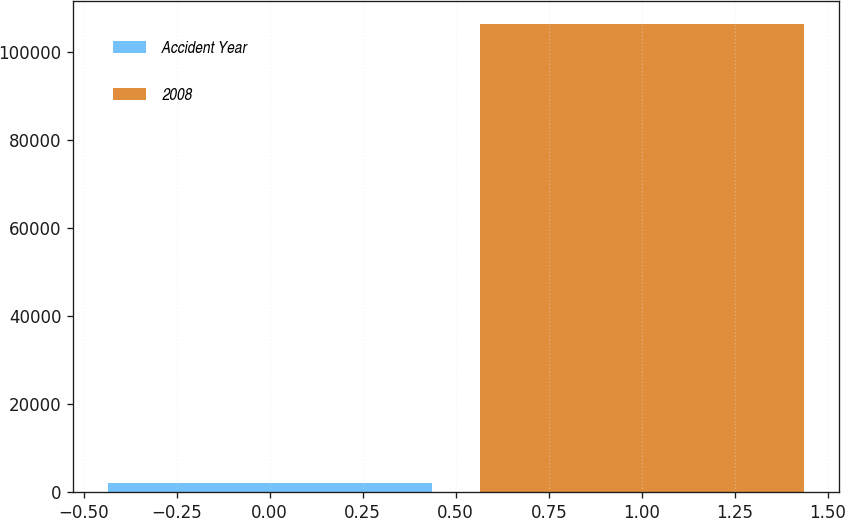Convert chart. <chart><loc_0><loc_0><loc_500><loc_500><bar_chart><fcel>Accident Year<fcel>2008<nl><fcel>2016<fcel>106428<nl></chart> 